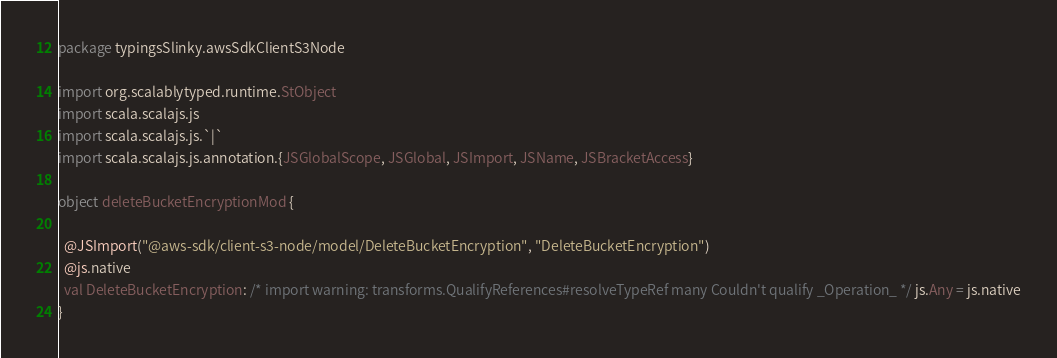Convert code to text. <code><loc_0><loc_0><loc_500><loc_500><_Scala_>package typingsSlinky.awsSdkClientS3Node

import org.scalablytyped.runtime.StObject
import scala.scalajs.js
import scala.scalajs.js.`|`
import scala.scalajs.js.annotation.{JSGlobalScope, JSGlobal, JSImport, JSName, JSBracketAccess}

object deleteBucketEncryptionMod {
  
  @JSImport("@aws-sdk/client-s3-node/model/DeleteBucketEncryption", "DeleteBucketEncryption")
  @js.native
  val DeleteBucketEncryption: /* import warning: transforms.QualifyReferences#resolveTypeRef many Couldn't qualify _Operation_ */ js.Any = js.native
}
</code> 